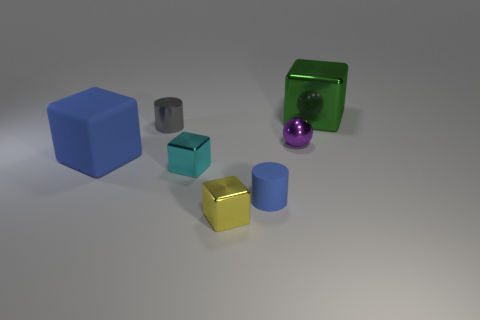What number of other things are the same material as the purple object?
Ensure brevity in your answer.  4. Are the large cube left of the tiny cyan object and the purple sphere made of the same material?
Provide a succinct answer. No. What size is the blue rubber thing in front of the matte object that is left of the cylinder that is to the left of the tiny matte cylinder?
Offer a very short reply. Small. What number of other objects are there of the same color as the matte cylinder?
Keep it short and to the point. 1. What is the shape of the matte object that is the same size as the yellow metallic object?
Give a very brief answer. Cylinder. There is a cylinder in front of the large blue thing; what is its size?
Keep it short and to the point. Small. There is a small metal thing right of the yellow metallic cube; is its color the same as the metal object that is behind the gray metallic cylinder?
Provide a succinct answer. No. The cube to the right of the matte object that is to the right of the tiny block to the right of the tiny cyan metal cube is made of what material?
Make the answer very short. Metal. Is there a cyan shiny thing of the same size as the yellow cube?
Keep it short and to the point. Yes. There is a green cube that is the same size as the blue matte cube; what is its material?
Offer a terse response. Metal. 